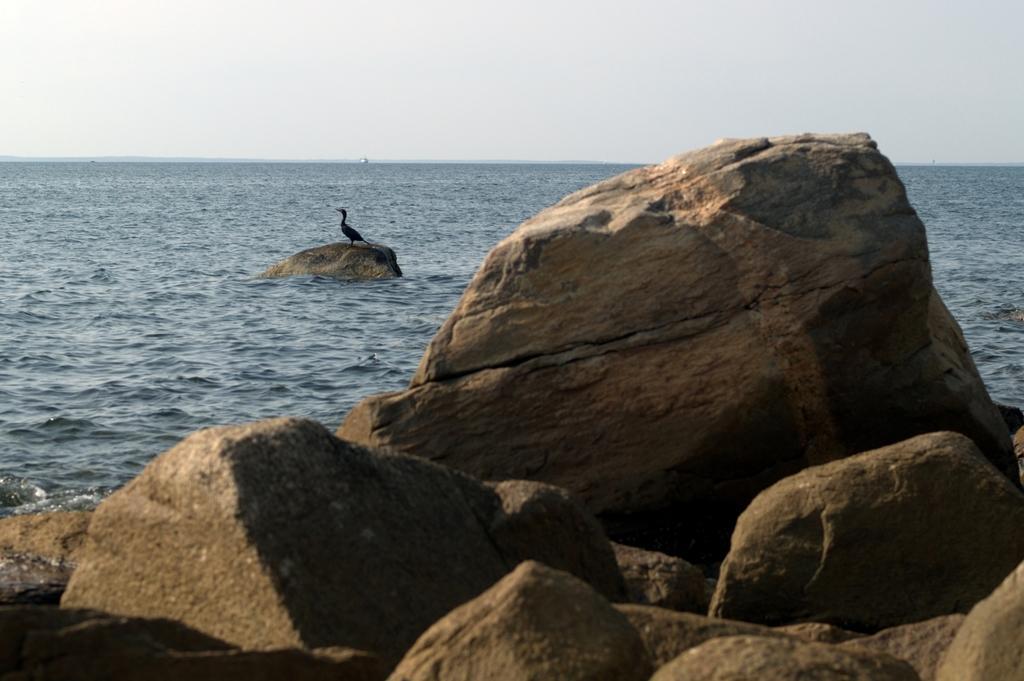In one or two sentences, can you explain what this image depicts? In this picture there are rocks at the bottom side of the image and there is a bird on the rock on the left side of the image and there is water in the background area of the image. 